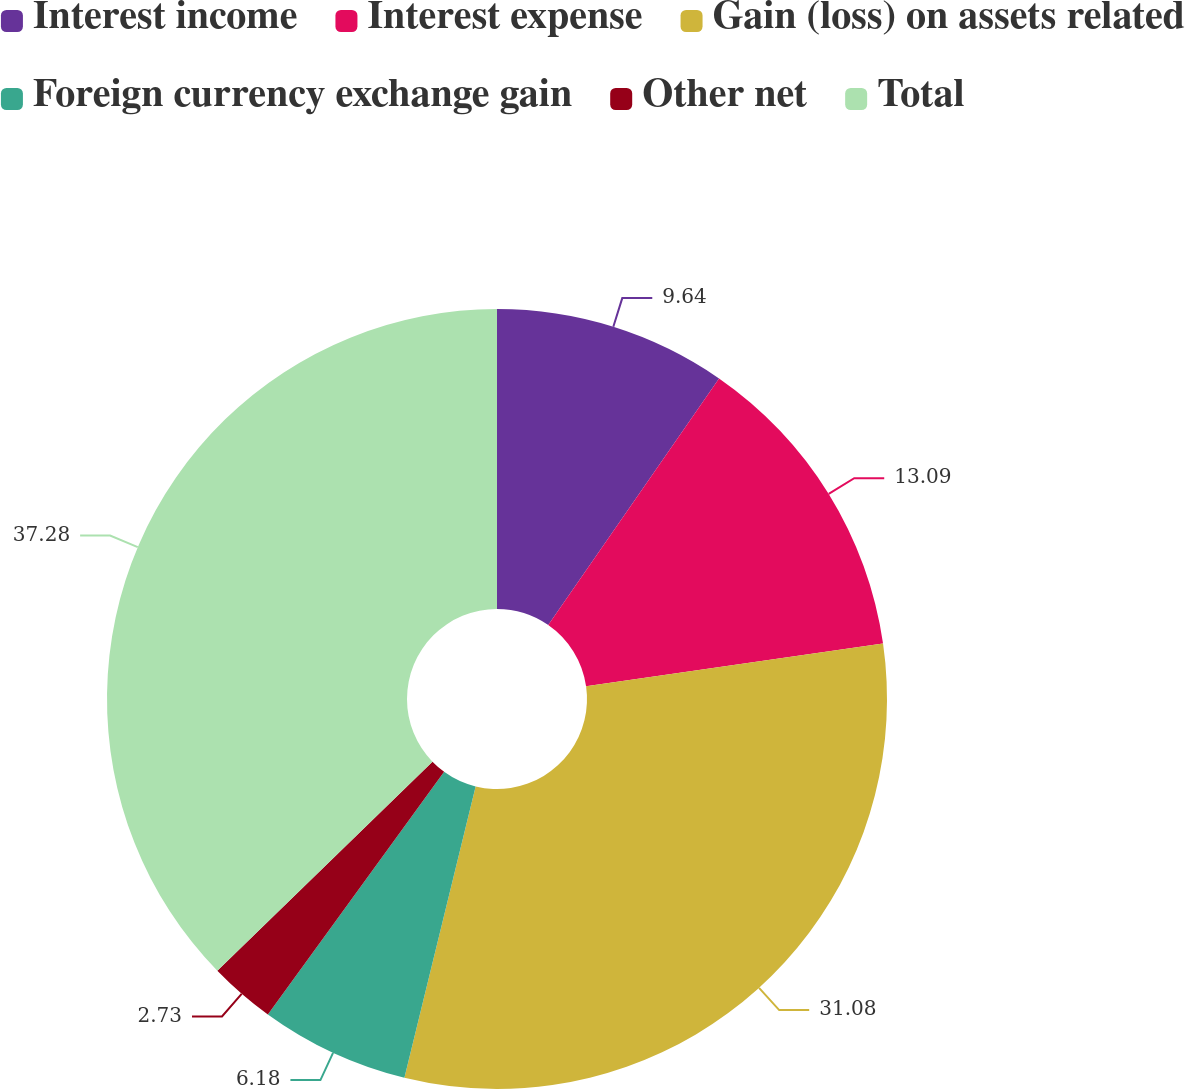Convert chart to OTSL. <chart><loc_0><loc_0><loc_500><loc_500><pie_chart><fcel>Interest income<fcel>Interest expense<fcel>Gain (loss) on assets related<fcel>Foreign currency exchange gain<fcel>Other net<fcel>Total<nl><fcel>9.64%<fcel>13.09%<fcel>31.08%<fcel>6.18%<fcel>2.73%<fcel>37.27%<nl></chart> 